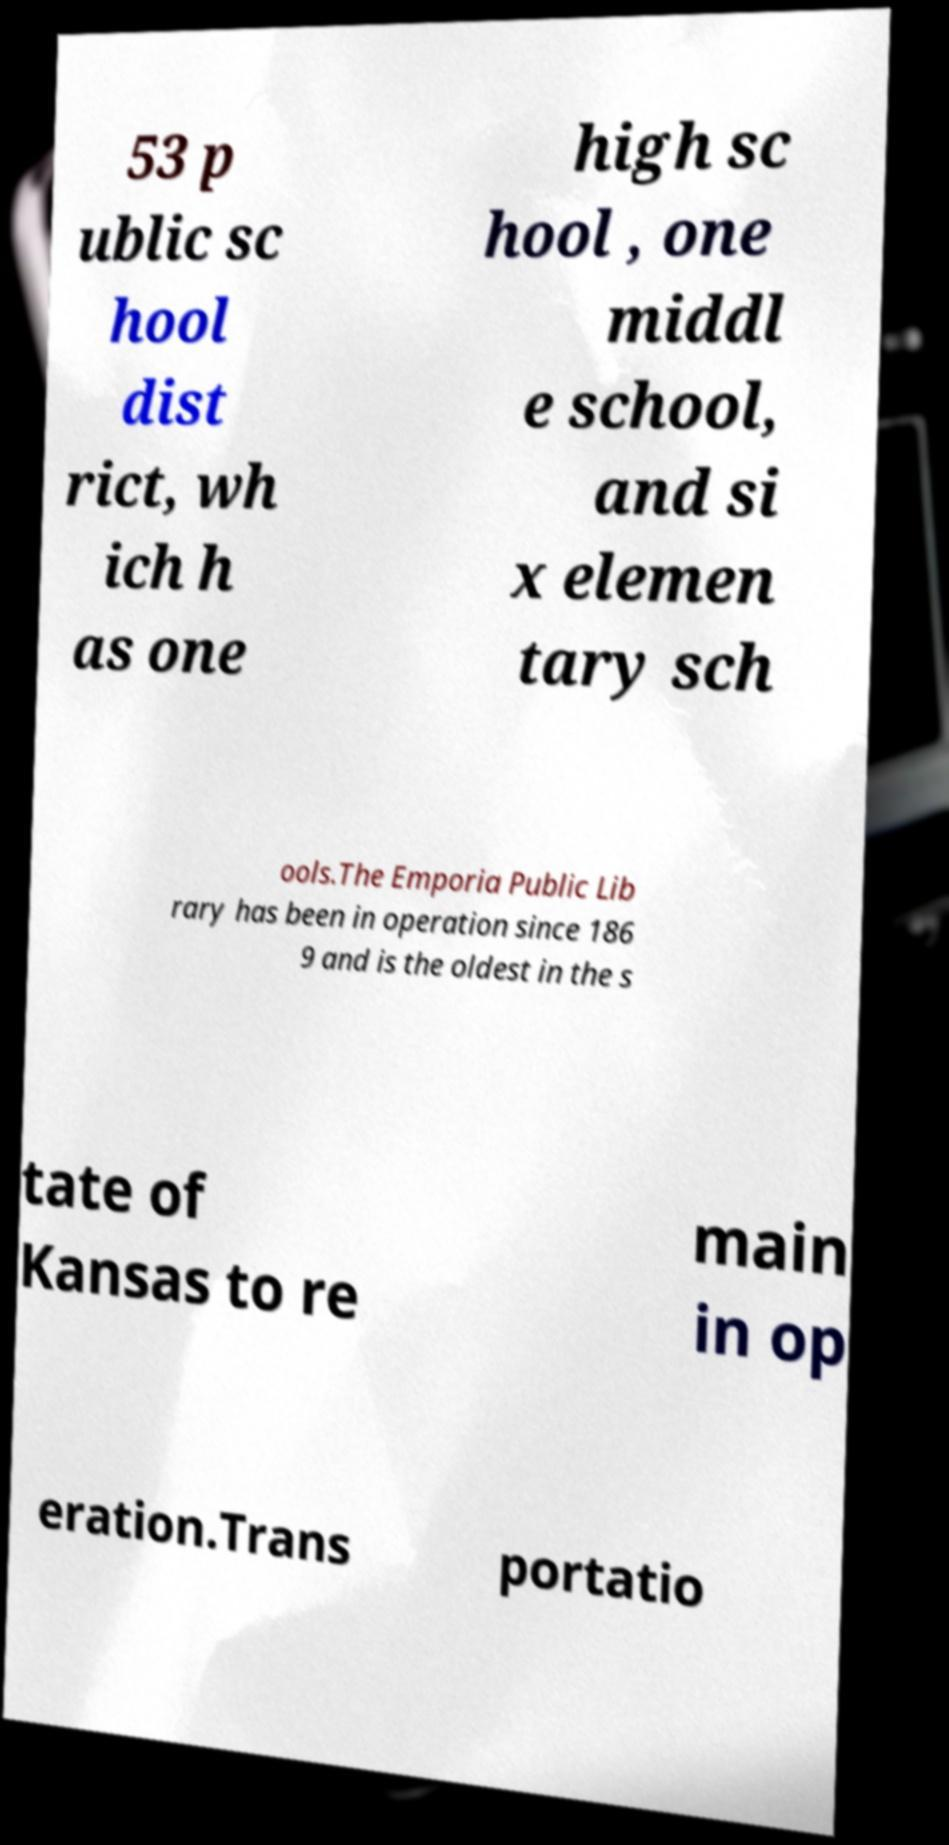Could you assist in decoding the text presented in this image and type it out clearly? 53 p ublic sc hool dist rict, wh ich h as one high sc hool , one middl e school, and si x elemen tary sch ools.The Emporia Public Lib rary has been in operation since 186 9 and is the oldest in the s tate of Kansas to re main in op eration.Trans portatio 